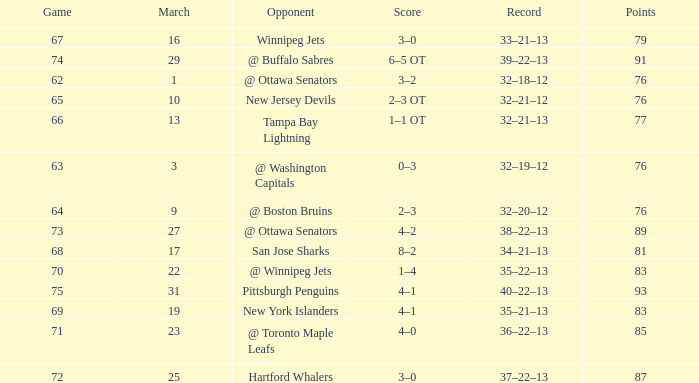Which Game is the lowest one that has a Score of 2–3 ot, and Points larger than 76? None. 